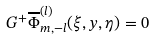Convert formula to latex. <formula><loc_0><loc_0><loc_500><loc_500>G ^ { + } \overline { \Phi } ^ { ( l ) } _ { m , - l } ( \xi , y , \eta ) = 0</formula> 